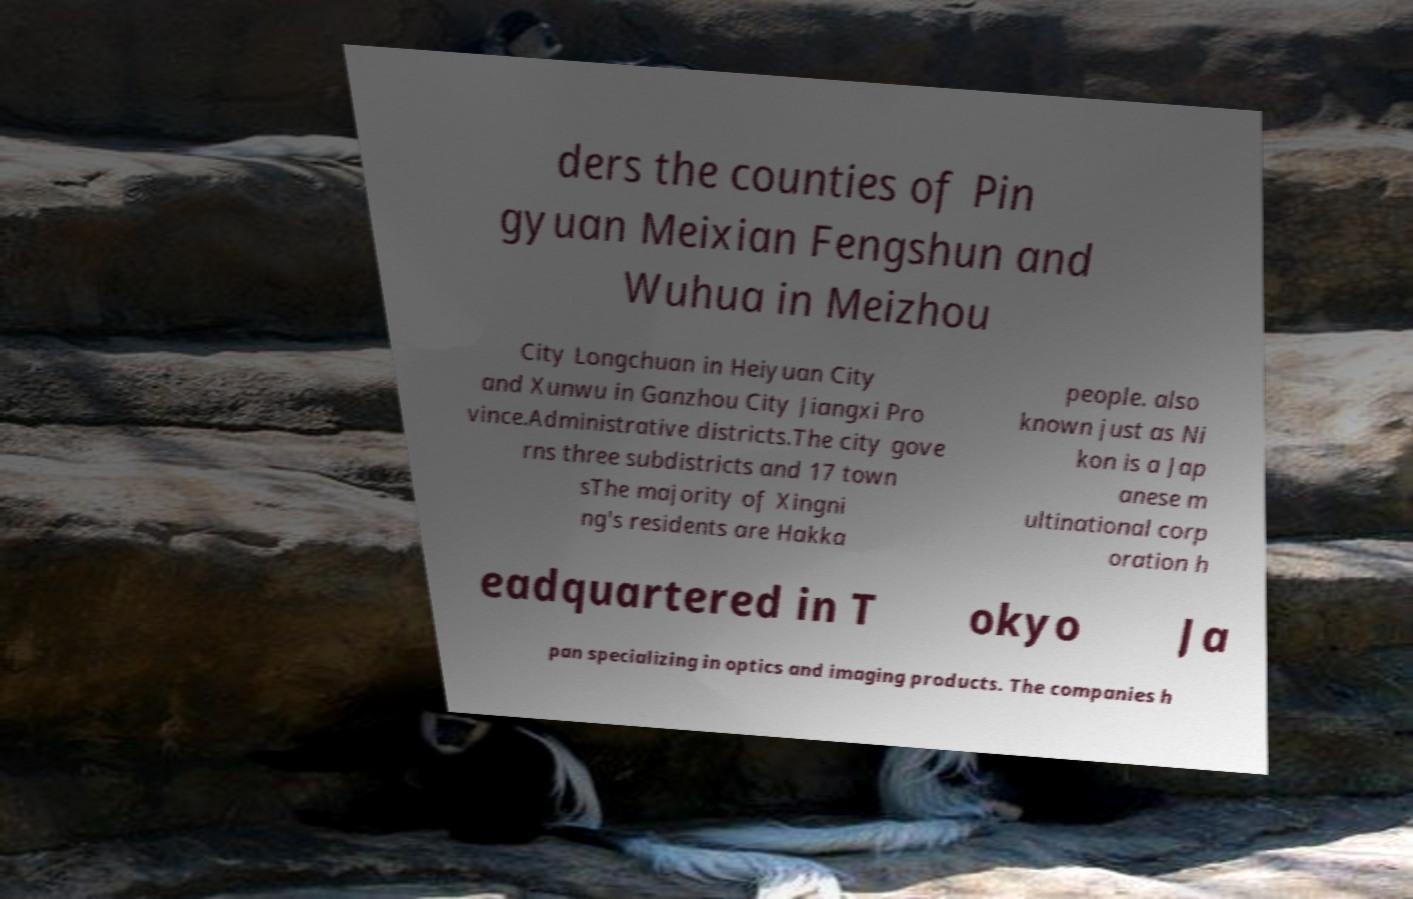For documentation purposes, I need the text within this image transcribed. Could you provide that? ders the counties of Pin gyuan Meixian Fengshun and Wuhua in Meizhou City Longchuan in Heiyuan City and Xunwu in Ganzhou City Jiangxi Pro vince.Administrative districts.The city gove rns three subdistricts and 17 town sThe majority of Xingni ng's residents are Hakka people. also known just as Ni kon is a Jap anese m ultinational corp oration h eadquartered in T okyo Ja pan specializing in optics and imaging products. The companies h 